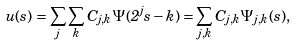<formula> <loc_0><loc_0><loc_500><loc_500>u ( s ) = \sum _ { j } \sum _ { k } C _ { j , k } \Psi ( 2 ^ { j } s - k ) = \sum _ { j , k } C _ { j , k } \Psi _ { j , k } ( s ) ,</formula> 